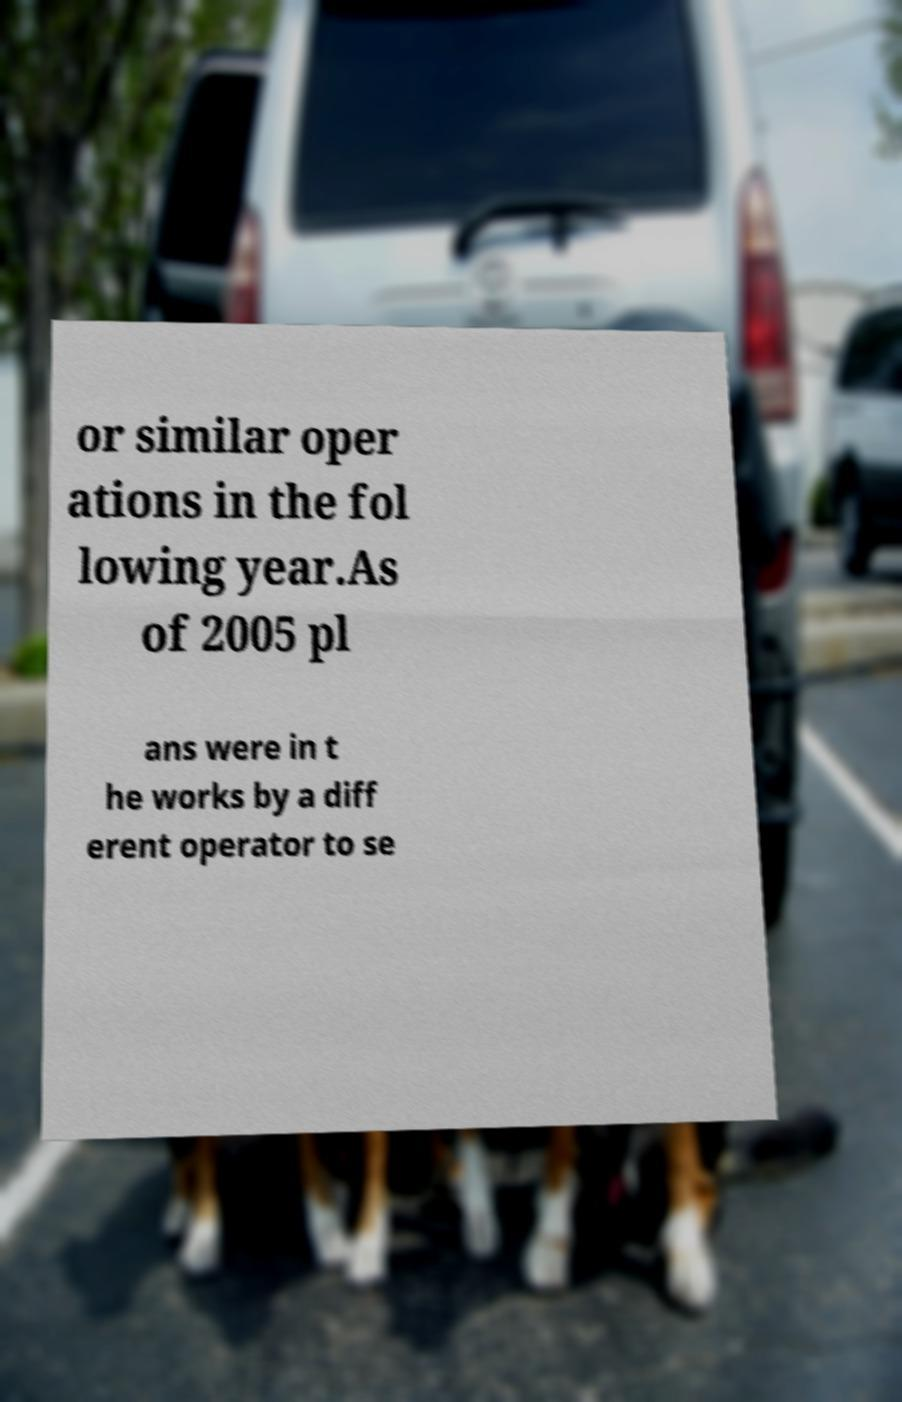Can you read and provide the text displayed in the image?This photo seems to have some interesting text. Can you extract and type it out for me? or similar oper ations in the fol lowing year.As of 2005 pl ans were in t he works by a diff erent operator to se 